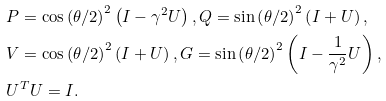Convert formula to latex. <formula><loc_0><loc_0><loc_500><loc_500>& P = \cos \left ( \theta / 2 \right ) ^ { 2 } \left ( I - \gamma ^ { 2 } U \right ) , Q = \sin \left ( \theta / 2 \right ) ^ { 2 } \left ( I + U \right ) , \\ & V = \cos \left ( \theta / 2 \right ) ^ { 2 } \left ( I + U \right ) , G = \sin \left ( \theta / 2 \right ) ^ { 2 } \left ( I - \frac { 1 } { \gamma ^ { 2 } } U \right ) , \\ & U ^ { T } U = I .</formula> 